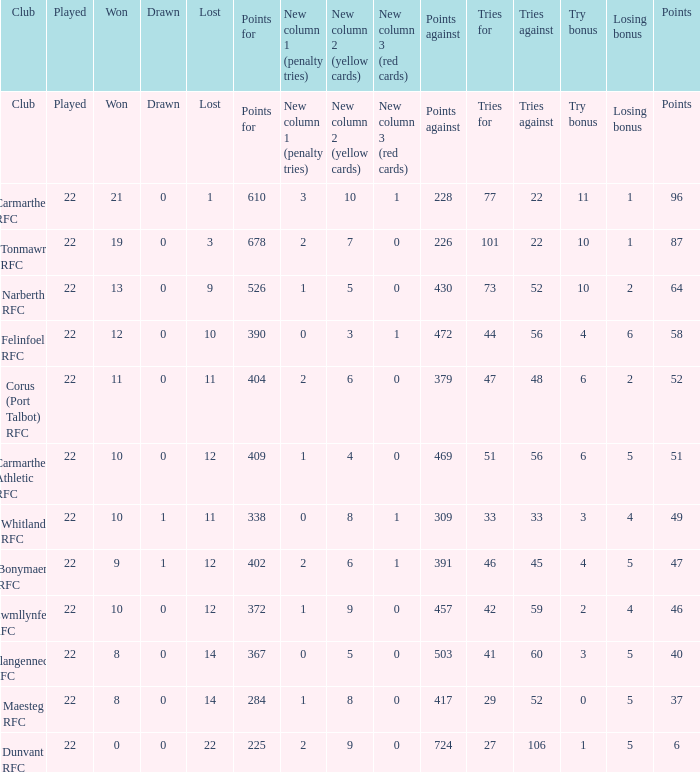Name the losing bonus for 27 5.0. 